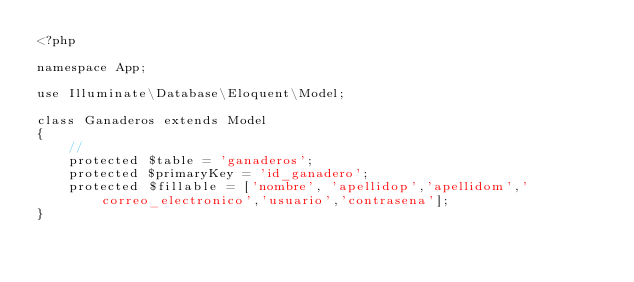Convert code to text. <code><loc_0><loc_0><loc_500><loc_500><_PHP_><?php

namespace App;

use Illuminate\Database\Eloquent\Model;

class Ganaderos extends Model
{
    //
    protected $table = 'ganaderos';
    protected $primaryKey = 'id_ganadero';
    protected $fillable = ['nombre', 'apellidop','apellidom','correo_electronico','usuario','contrasena'];
}
</code> 